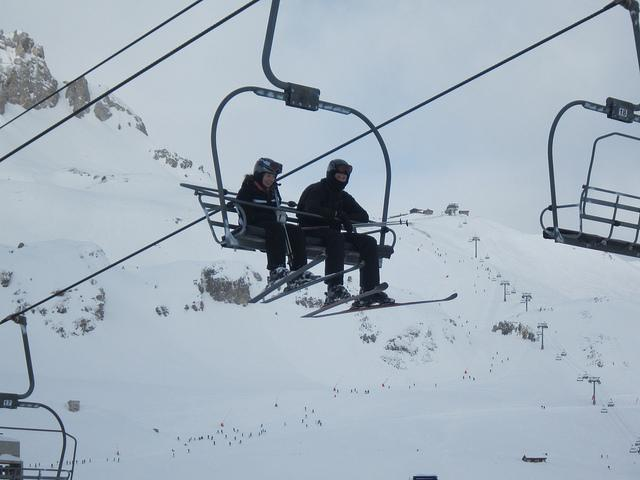The ski lift saves the skiers from a lot of what physical activity?

Choices:
A) rollerskating
B) swimming
C) walking
D) skipping walking 